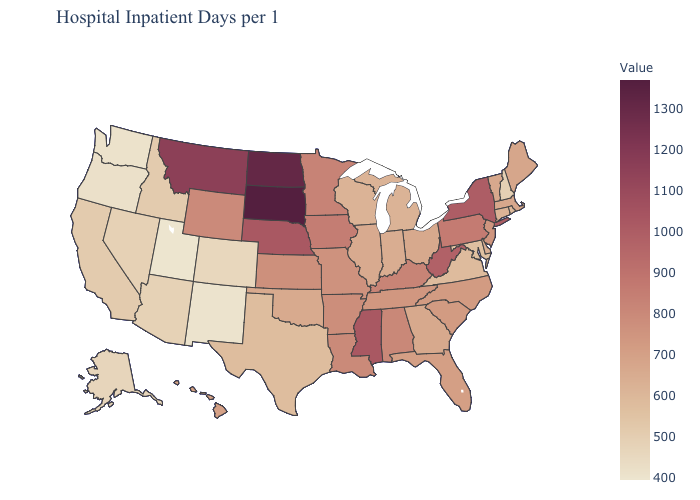Among the states that border Ohio , does Michigan have the lowest value?
Quick response, please. Yes. Which states have the highest value in the USA?
Give a very brief answer. South Dakota. Among the states that border West Virginia , which have the highest value?
Short answer required. Pennsylvania. Which states hav the highest value in the MidWest?
Keep it brief. South Dakota. Which states have the lowest value in the South?
Keep it brief. Maryland. Which states hav the highest value in the Northeast?
Write a very short answer. New York. Does Maryland have a lower value than Colorado?
Quick response, please. No. Which states have the highest value in the USA?
Concise answer only. South Dakota. Which states have the lowest value in the West?
Quick response, please. Utah. 